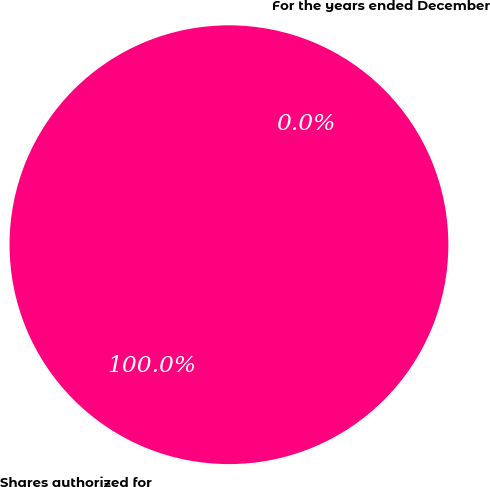Convert chart to OTSL. <chart><loc_0><loc_0><loc_500><loc_500><pie_chart><fcel>For the years ended December<fcel>Shares authorized for<nl><fcel>0.0%<fcel>100.0%<nl></chart> 